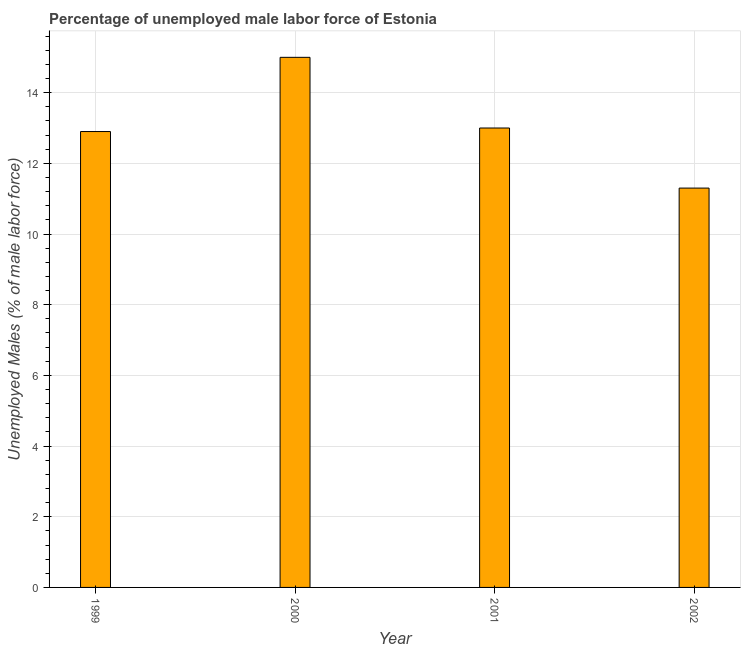What is the title of the graph?
Your response must be concise. Percentage of unemployed male labor force of Estonia. What is the label or title of the X-axis?
Offer a very short reply. Year. What is the label or title of the Y-axis?
Your answer should be very brief. Unemployed Males (% of male labor force). What is the total unemployed male labour force in 2000?
Your response must be concise. 15. Across all years, what is the minimum total unemployed male labour force?
Offer a very short reply. 11.3. In which year was the total unemployed male labour force maximum?
Make the answer very short. 2000. In which year was the total unemployed male labour force minimum?
Offer a very short reply. 2002. What is the sum of the total unemployed male labour force?
Ensure brevity in your answer.  52.2. What is the difference between the total unemployed male labour force in 2000 and 2001?
Provide a succinct answer. 2. What is the average total unemployed male labour force per year?
Ensure brevity in your answer.  13.05. What is the median total unemployed male labour force?
Ensure brevity in your answer.  12.95. In how many years, is the total unemployed male labour force greater than 5.6 %?
Provide a short and direct response. 4. Do a majority of the years between 2002 and 1999 (inclusive) have total unemployed male labour force greater than 9.2 %?
Offer a terse response. Yes. What is the ratio of the total unemployed male labour force in 1999 to that in 2001?
Ensure brevity in your answer.  0.99. Is the total unemployed male labour force in 2000 less than that in 2001?
Make the answer very short. No. What is the difference between the highest and the second highest total unemployed male labour force?
Provide a succinct answer. 2. What is the difference between the highest and the lowest total unemployed male labour force?
Provide a succinct answer. 3.7. In how many years, is the total unemployed male labour force greater than the average total unemployed male labour force taken over all years?
Offer a terse response. 1. How many bars are there?
Your response must be concise. 4. Are all the bars in the graph horizontal?
Keep it short and to the point. No. Are the values on the major ticks of Y-axis written in scientific E-notation?
Offer a terse response. No. What is the Unemployed Males (% of male labor force) of 1999?
Keep it short and to the point. 12.9. What is the Unemployed Males (% of male labor force) in 2002?
Give a very brief answer. 11.3. What is the difference between the Unemployed Males (% of male labor force) in 1999 and 2002?
Your response must be concise. 1.6. What is the difference between the Unemployed Males (% of male labor force) in 2000 and 2002?
Keep it short and to the point. 3.7. What is the difference between the Unemployed Males (% of male labor force) in 2001 and 2002?
Your response must be concise. 1.7. What is the ratio of the Unemployed Males (% of male labor force) in 1999 to that in 2000?
Offer a terse response. 0.86. What is the ratio of the Unemployed Males (% of male labor force) in 1999 to that in 2002?
Your answer should be compact. 1.14. What is the ratio of the Unemployed Males (% of male labor force) in 2000 to that in 2001?
Ensure brevity in your answer.  1.15. What is the ratio of the Unemployed Males (% of male labor force) in 2000 to that in 2002?
Offer a terse response. 1.33. What is the ratio of the Unemployed Males (% of male labor force) in 2001 to that in 2002?
Make the answer very short. 1.15. 